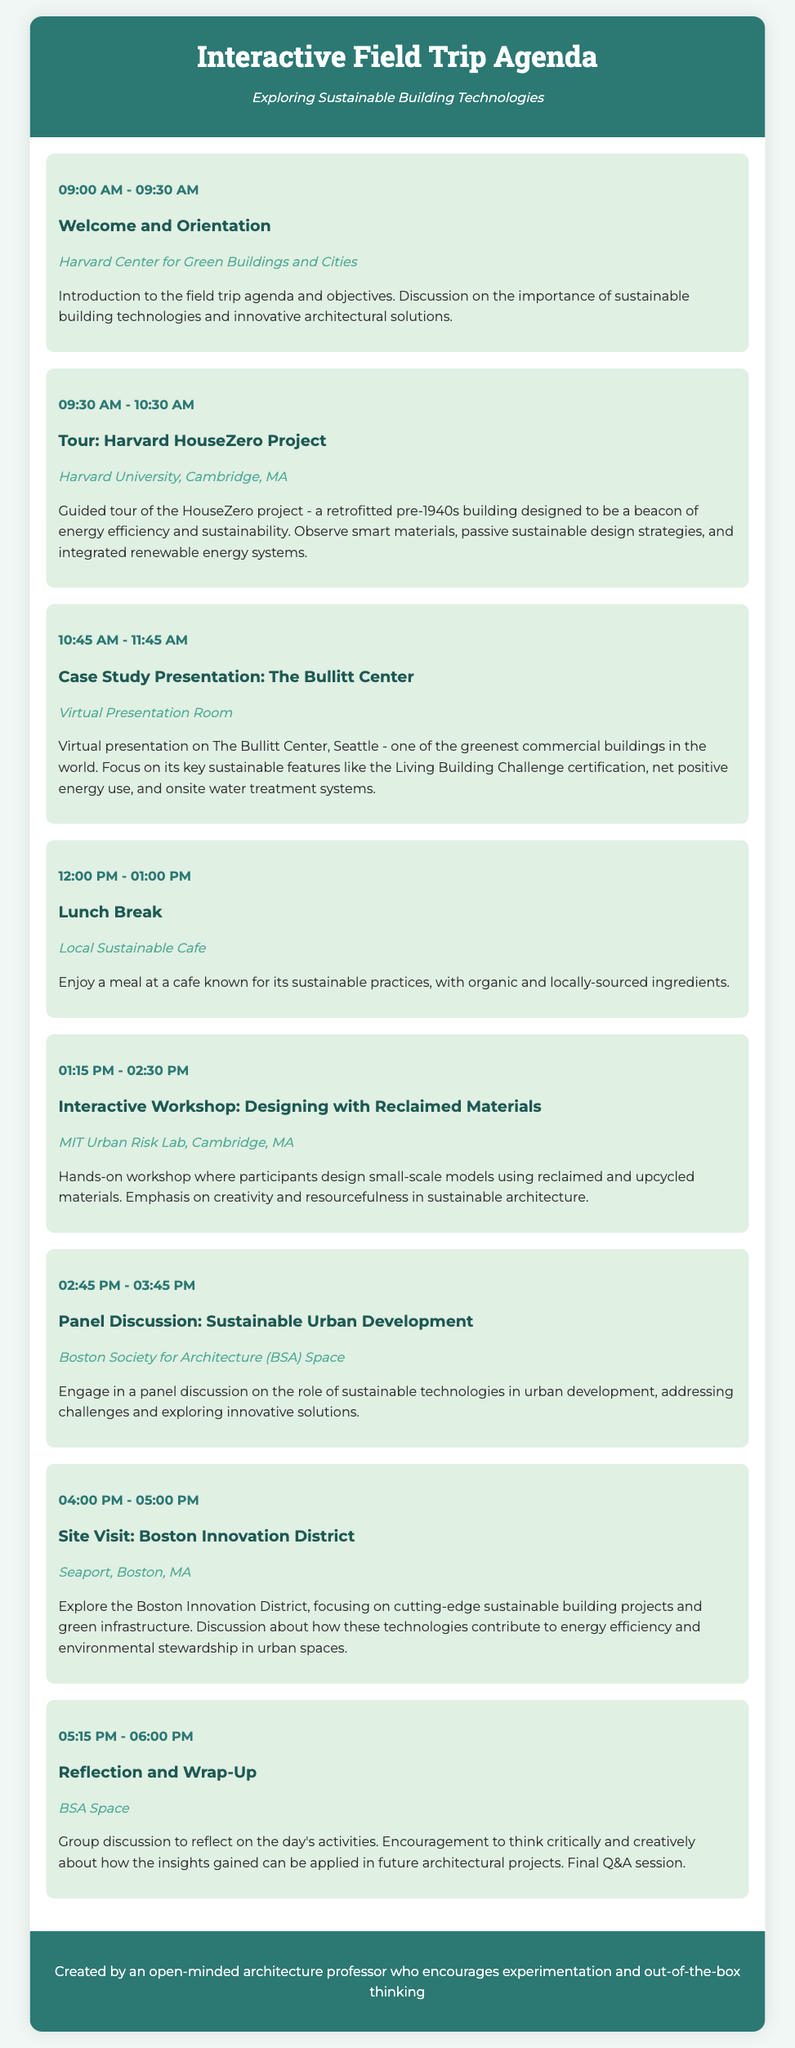What time does the lunch break start? The lunch break starts at 12:00 PM as stated in the agenda.
Answer: 12:00 PM What location is the Reflection and Wrap-Up held at? The Reflection and Wrap-Up is held at the BSA Space according to the document.
Answer: BSA Space What activity takes place at 01:15 PM? The activity taking place at 01:15 PM is an interactive workshop on designing with reclaimed materials.
Answer: Interactive Workshop: Designing with Reclaimed Materials How long is the site visit at the Boston Innovation District? The site visit is scheduled for one hour, starting at 04:00 PM and ending at 05:00 PM.
Answer: One hour What building is highlighted in the case study presentation? The Bullitt Center in Seattle is the focus of the case study presentation as noted in the agenda.
Answer: The Bullitt Center What is the primary theme of the field trip? The primary theme of the field trip is exploring sustainable building technologies.
Answer: Sustainable building technologies What type of activity is included before the lunch break? Before the lunch break, there is a case study presentation scheduled at a virtual presentation room.
Answer: Case Study Presentation How many agenda items are there in total? There are eight agenda items listed in the document, including welcome and orientation.
Answer: Eight 